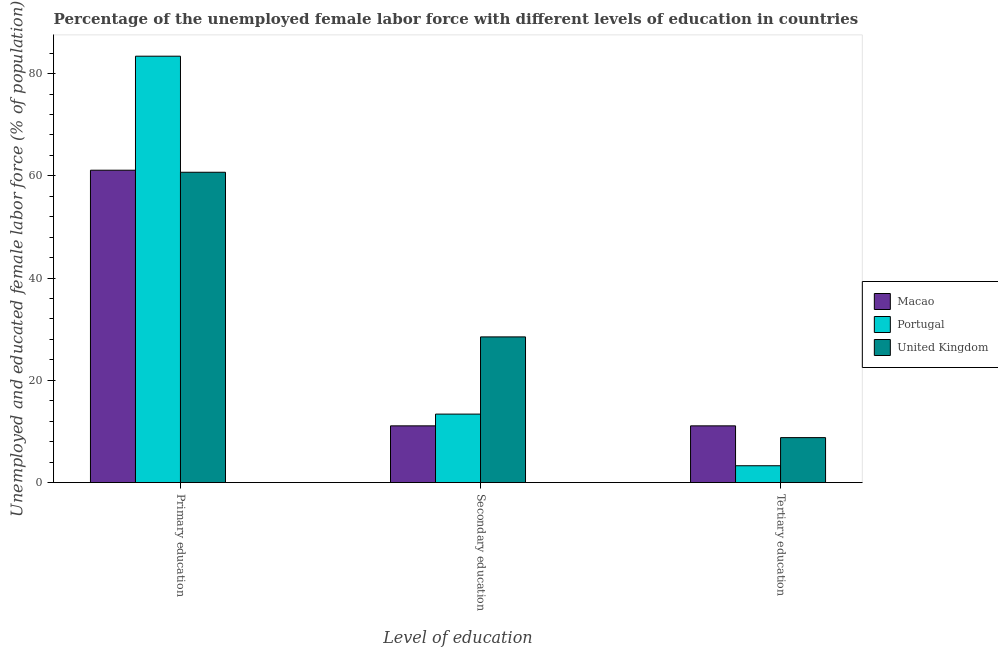How many different coloured bars are there?
Your answer should be very brief. 3. Are the number of bars per tick equal to the number of legend labels?
Your response must be concise. Yes. Are the number of bars on each tick of the X-axis equal?
Provide a short and direct response. Yes. How many bars are there on the 2nd tick from the left?
Your answer should be very brief. 3. What is the label of the 2nd group of bars from the left?
Give a very brief answer. Secondary education. What is the percentage of female labor force who received tertiary education in Macao?
Provide a short and direct response. 11.1. Across all countries, what is the minimum percentage of female labor force who received secondary education?
Offer a terse response. 11.1. In which country was the percentage of female labor force who received secondary education minimum?
Offer a very short reply. Macao. What is the total percentage of female labor force who received primary education in the graph?
Ensure brevity in your answer.  205.2. What is the difference between the percentage of female labor force who received secondary education in United Kingdom and that in Portugal?
Your response must be concise. 15.1. What is the difference between the percentage of female labor force who received secondary education in Portugal and the percentage of female labor force who received tertiary education in Macao?
Your answer should be very brief. 2.3. What is the average percentage of female labor force who received secondary education per country?
Your answer should be very brief. 17.67. What is the difference between the percentage of female labor force who received secondary education and percentage of female labor force who received primary education in Macao?
Provide a succinct answer. -50. In how many countries, is the percentage of female labor force who received secondary education greater than 72 %?
Offer a terse response. 0. What is the ratio of the percentage of female labor force who received secondary education in Portugal to that in United Kingdom?
Your answer should be compact. 0.47. Is the percentage of female labor force who received primary education in Portugal less than that in Macao?
Keep it short and to the point. No. Is the difference between the percentage of female labor force who received primary education in Macao and Portugal greater than the difference between the percentage of female labor force who received tertiary education in Macao and Portugal?
Your answer should be compact. No. What is the difference between the highest and the second highest percentage of female labor force who received tertiary education?
Give a very brief answer. 2.3. What is the difference between the highest and the lowest percentage of female labor force who received secondary education?
Your answer should be very brief. 17.4. In how many countries, is the percentage of female labor force who received secondary education greater than the average percentage of female labor force who received secondary education taken over all countries?
Make the answer very short. 1. Is the sum of the percentage of female labor force who received tertiary education in United Kingdom and Portugal greater than the maximum percentage of female labor force who received primary education across all countries?
Offer a terse response. No. What does the 2nd bar from the right in Tertiary education represents?
Your answer should be very brief. Portugal. How many bars are there?
Provide a succinct answer. 9. What is the difference between two consecutive major ticks on the Y-axis?
Your answer should be compact. 20. Does the graph contain any zero values?
Make the answer very short. No. Where does the legend appear in the graph?
Give a very brief answer. Center right. What is the title of the graph?
Provide a short and direct response. Percentage of the unemployed female labor force with different levels of education in countries. Does "Venezuela" appear as one of the legend labels in the graph?
Give a very brief answer. No. What is the label or title of the X-axis?
Offer a terse response. Level of education. What is the label or title of the Y-axis?
Keep it short and to the point. Unemployed and educated female labor force (% of population). What is the Unemployed and educated female labor force (% of population) in Macao in Primary education?
Offer a very short reply. 61.1. What is the Unemployed and educated female labor force (% of population) of Portugal in Primary education?
Your response must be concise. 83.4. What is the Unemployed and educated female labor force (% of population) in United Kingdom in Primary education?
Provide a succinct answer. 60.7. What is the Unemployed and educated female labor force (% of population) in Macao in Secondary education?
Your answer should be very brief. 11.1. What is the Unemployed and educated female labor force (% of population) in Portugal in Secondary education?
Provide a short and direct response. 13.4. What is the Unemployed and educated female labor force (% of population) in Macao in Tertiary education?
Ensure brevity in your answer.  11.1. What is the Unemployed and educated female labor force (% of population) in Portugal in Tertiary education?
Keep it short and to the point. 3.3. What is the Unemployed and educated female labor force (% of population) in United Kingdom in Tertiary education?
Provide a short and direct response. 8.8. Across all Level of education, what is the maximum Unemployed and educated female labor force (% of population) in Macao?
Your response must be concise. 61.1. Across all Level of education, what is the maximum Unemployed and educated female labor force (% of population) of Portugal?
Keep it short and to the point. 83.4. Across all Level of education, what is the maximum Unemployed and educated female labor force (% of population) in United Kingdom?
Your response must be concise. 60.7. Across all Level of education, what is the minimum Unemployed and educated female labor force (% of population) in Macao?
Ensure brevity in your answer.  11.1. Across all Level of education, what is the minimum Unemployed and educated female labor force (% of population) of Portugal?
Provide a short and direct response. 3.3. Across all Level of education, what is the minimum Unemployed and educated female labor force (% of population) of United Kingdom?
Give a very brief answer. 8.8. What is the total Unemployed and educated female labor force (% of population) in Macao in the graph?
Provide a short and direct response. 83.3. What is the total Unemployed and educated female labor force (% of population) of Portugal in the graph?
Give a very brief answer. 100.1. What is the difference between the Unemployed and educated female labor force (% of population) of Portugal in Primary education and that in Secondary education?
Offer a terse response. 70. What is the difference between the Unemployed and educated female labor force (% of population) of United Kingdom in Primary education and that in Secondary education?
Provide a succinct answer. 32.2. What is the difference between the Unemployed and educated female labor force (% of population) in Portugal in Primary education and that in Tertiary education?
Your response must be concise. 80.1. What is the difference between the Unemployed and educated female labor force (% of population) of United Kingdom in Primary education and that in Tertiary education?
Your answer should be compact. 51.9. What is the difference between the Unemployed and educated female labor force (% of population) in Macao in Secondary education and that in Tertiary education?
Make the answer very short. 0. What is the difference between the Unemployed and educated female labor force (% of population) in Portugal in Secondary education and that in Tertiary education?
Make the answer very short. 10.1. What is the difference between the Unemployed and educated female labor force (% of population) of Macao in Primary education and the Unemployed and educated female labor force (% of population) of Portugal in Secondary education?
Make the answer very short. 47.7. What is the difference between the Unemployed and educated female labor force (% of population) in Macao in Primary education and the Unemployed and educated female labor force (% of population) in United Kingdom in Secondary education?
Your response must be concise. 32.6. What is the difference between the Unemployed and educated female labor force (% of population) of Portugal in Primary education and the Unemployed and educated female labor force (% of population) of United Kingdom in Secondary education?
Offer a very short reply. 54.9. What is the difference between the Unemployed and educated female labor force (% of population) in Macao in Primary education and the Unemployed and educated female labor force (% of population) in Portugal in Tertiary education?
Offer a terse response. 57.8. What is the difference between the Unemployed and educated female labor force (% of population) in Macao in Primary education and the Unemployed and educated female labor force (% of population) in United Kingdom in Tertiary education?
Make the answer very short. 52.3. What is the difference between the Unemployed and educated female labor force (% of population) in Portugal in Primary education and the Unemployed and educated female labor force (% of population) in United Kingdom in Tertiary education?
Make the answer very short. 74.6. What is the average Unemployed and educated female labor force (% of population) in Macao per Level of education?
Your answer should be very brief. 27.77. What is the average Unemployed and educated female labor force (% of population) in Portugal per Level of education?
Ensure brevity in your answer.  33.37. What is the average Unemployed and educated female labor force (% of population) of United Kingdom per Level of education?
Make the answer very short. 32.67. What is the difference between the Unemployed and educated female labor force (% of population) of Macao and Unemployed and educated female labor force (% of population) of Portugal in Primary education?
Keep it short and to the point. -22.3. What is the difference between the Unemployed and educated female labor force (% of population) in Portugal and Unemployed and educated female labor force (% of population) in United Kingdom in Primary education?
Offer a terse response. 22.7. What is the difference between the Unemployed and educated female labor force (% of population) in Macao and Unemployed and educated female labor force (% of population) in Portugal in Secondary education?
Your answer should be compact. -2.3. What is the difference between the Unemployed and educated female labor force (% of population) in Macao and Unemployed and educated female labor force (% of population) in United Kingdom in Secondary education?
Your answer should be very brief. -17.4. What is the difference between the Unemployed and educated female labor force (% of population) in Portugal and Unemployed and educated female labor force (% of population) in United Kingdom in Secondary education?
Your answer should be compact. -15.1. What is the difference between the Unemployed and educated female labor force (% of population) in Macao and Unemployed and educated female labor force (% of population) in Portugal in Tertiary education?
Offer a very short reply. 7.8. What is the difference between the Unemployed and educated female labor force (% of population) of Macao and Unemployed and educated female labor force (% of population) of United Kingdom in Tertiary education?
Your response must be concise. 2.3. What is the ratio of the Unemployed and educated female labor force (% of population) in Macao in Primary education to that in Secondary education?
Keep it short and to the point. 5.5. What is the ratio of the Unemployed and educated female labor force (% of population) of Portugal in Primary education to that in Secondary education?
Keep it short and to the point. 6.22. What is the ratio of the Unemployed and educated female labor force (% of population) in United Kingdom in Primary education to that in Secondary education?
Your answer should be compact. 2.13. What is the ratio of the Unemployed and educated female labor force (% of population) in Macao in Primary education to that in Tertiary education?
Keep it short and to the point. 5.5. What is the ratio of the Unemployed and educated female labor force (% of population) in Portugal in Primary education to that in Tertiary education?
Give a very brief answer. 25.27. What is the ratio of the Unemployed and educated female labor force (% of population) in United Kingdom in Primary education to that in Tertiary education?
Offer a very short reply. 6.9. What is the ratio of the Unemployed and educated female labor force (% of population) in Macao in Secondary education to that in Tertiary education?
Provide a short and direct response. 1. What is the ratio of the Unemployed and educated female labor force (% of population) in Portugal in Secondary education to that in Tertiary education?
Give a very brief answer. 4.06. What is the ratio of the Unemployed and educated female labor force (% of population) in United Kingdom in Secondary education to that in Tertiary education?
Ensure brevity in your answer.  3.24. What is the difference between the highest and the second highest Unemployed and educated female labor force (% of population) in Macao?
Give a very brief answer. 50. What is the difference between the highest and the second highest Unemployed and educated female labor force (% of population) in Portugal?
Offer a terse response. 70. What is the difference between the highest and the second highest Unemployed and educated female labor force (% of population) in United Kingdom?
Offer a terse response. 32.2. What is the difference between the highest and the lowest Unemployed and educated female labor force (% of population) of Macao?
Your answer should be compact. 50. What is the difference between the highest and the lowest Unemployed and educated female labor force (% of population) of Portugal?
Ensure brevity in your answer.  80.1. What is the difference between the highest and the lowest Unemployed and educated female labor force (% of population) of United Kingdom?
Your answer should be very brief. 51.9. 